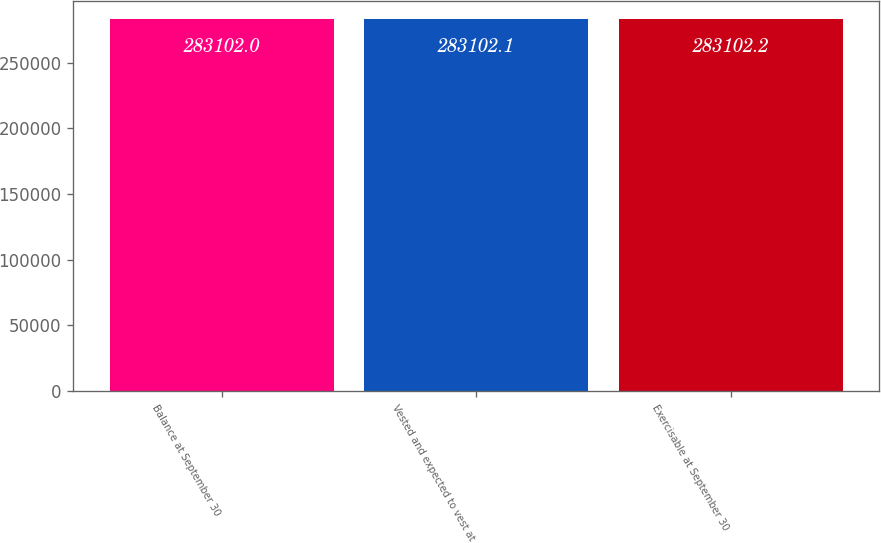Convert chart. <chart><loc_0><loc_0><loc_500><loc_500><bar_chart><fcel>Balance at September 30<fcel>Vested and expected to vest at<fcel>Exercisable at September 30<nl><fcel>283102<fcel>283102<fcel>283102<nl></chart> 